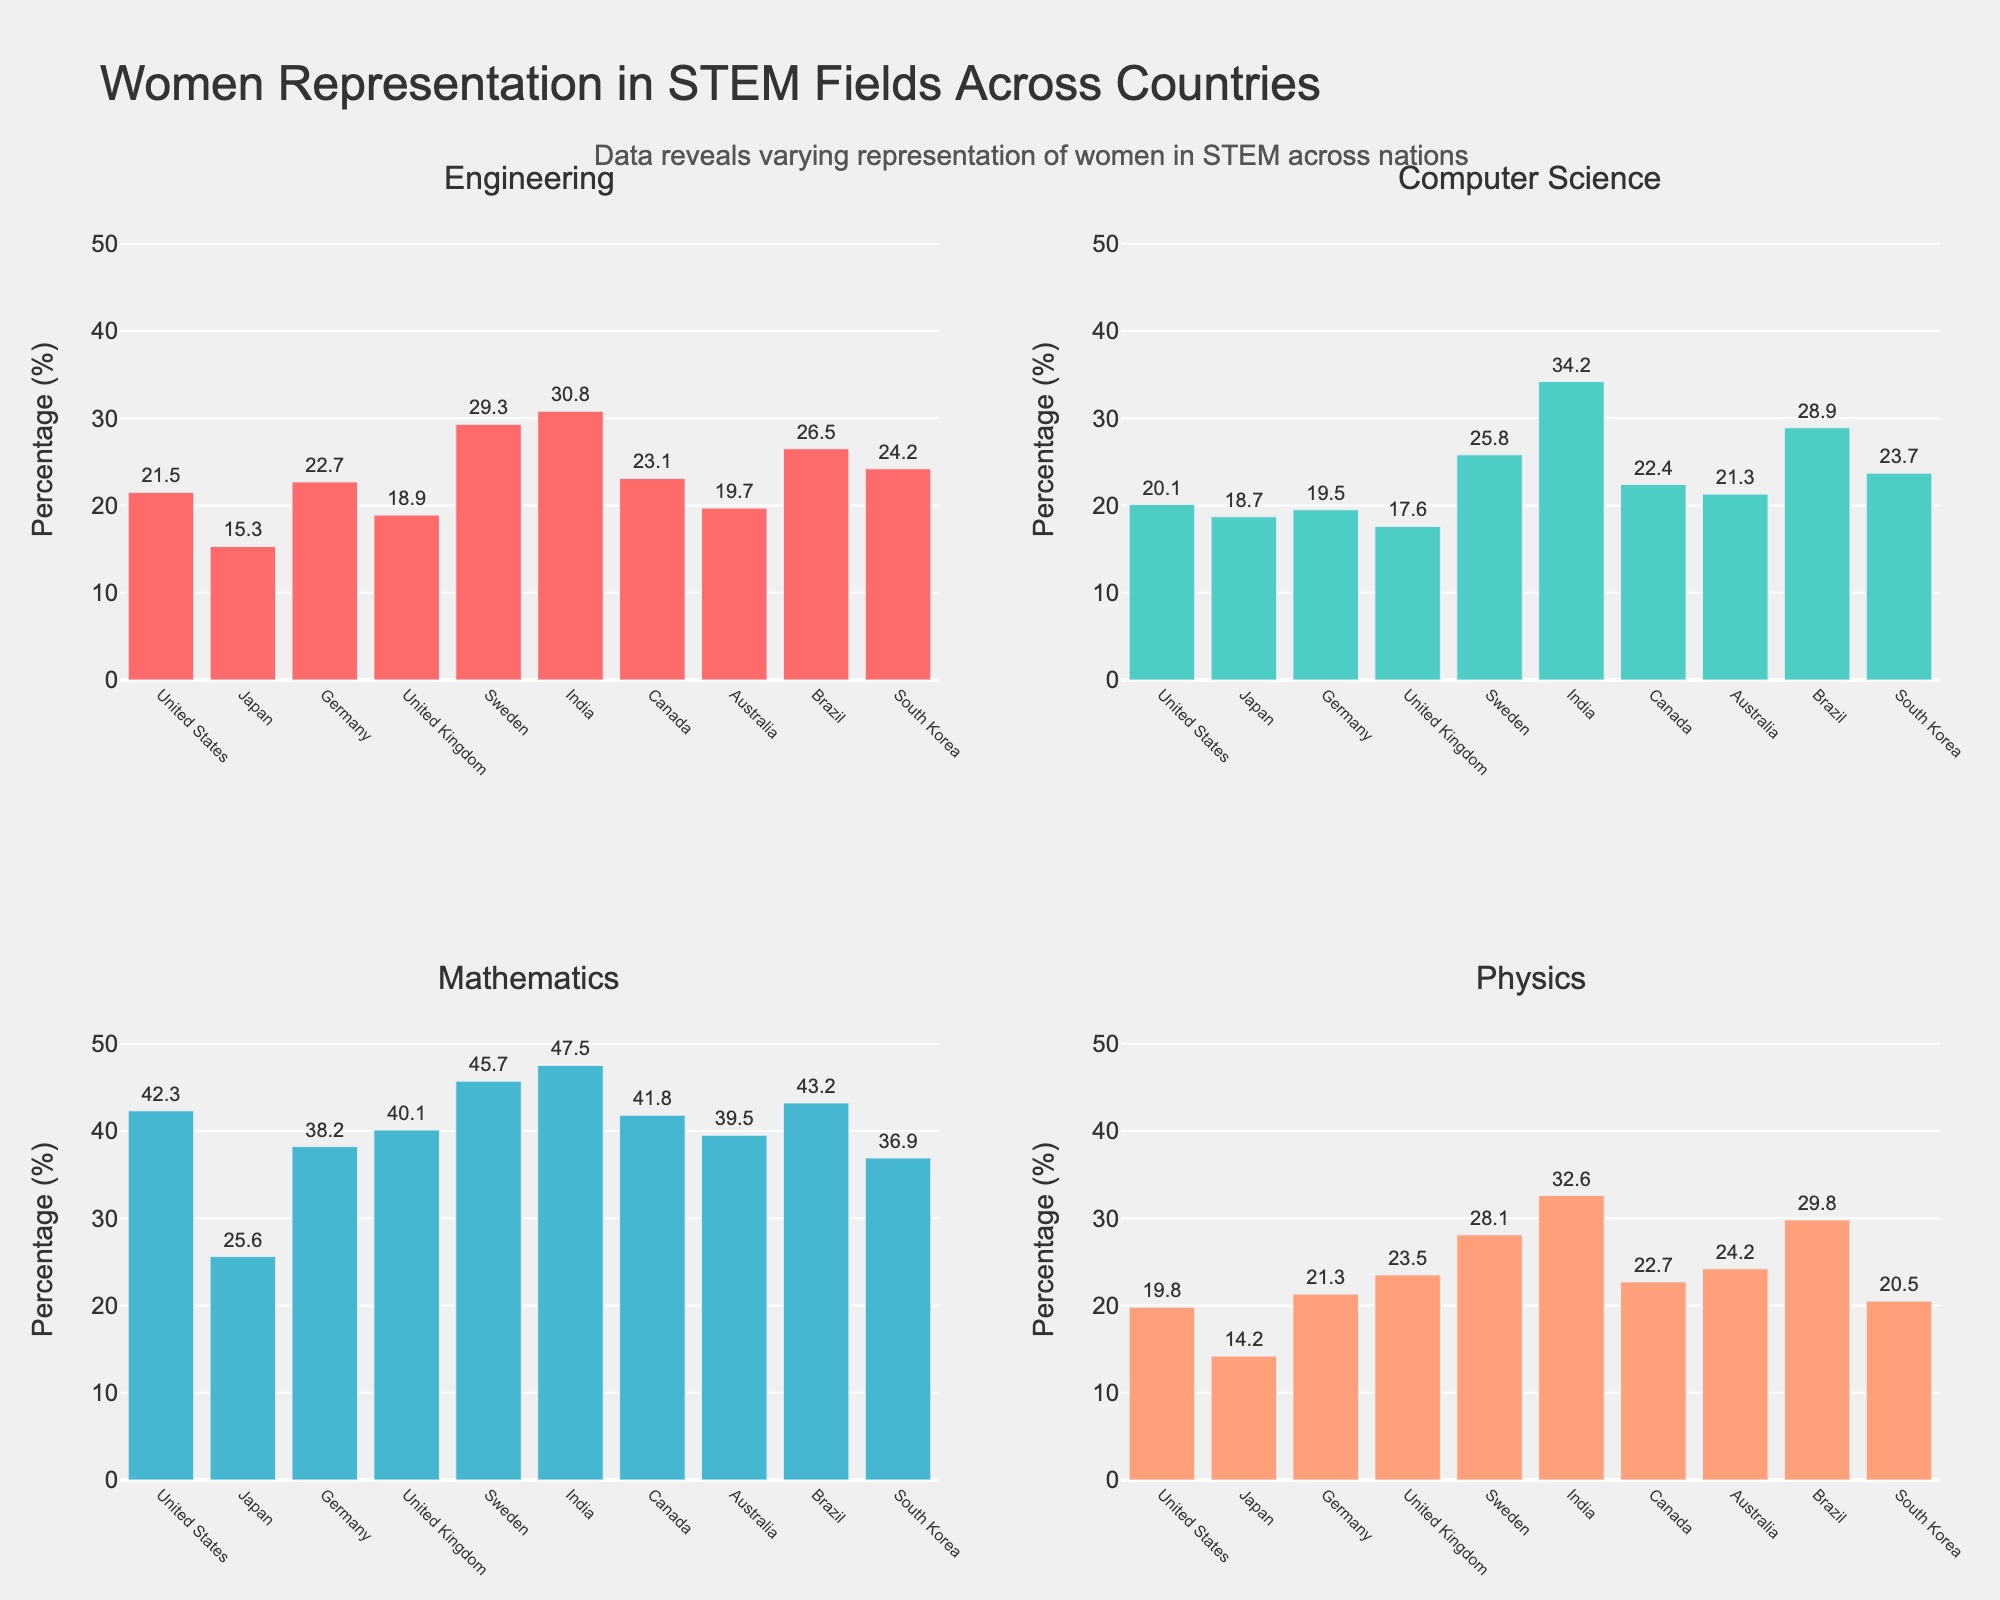How many publications were there in "Nature" in 2022? To answer this, locate the subplot for "Nature" and check the data point corresponding to the year 2022.
Answer: 67 Which journal saw the highest number of publications in 2019? Look at the subplots and identify the highest publication number in 2019. The subplot where this value appears indicates the journal with the highest publications.
Answer: ACS Sustainable Chemistry & Engineering Between which two consecutive years did "Biomacromolecules" see the greatest increase in publications? Identify the "Biomacromolecules" subplot and calculate the year-to-year publication differences; the greatest difference will indicate the years in question.
Answer: 2013-2014 What is the average number of publications across all journals in 2020? Sum the number of publications for 2020 across all journals and divide by the total number of journals. The journals are: Nature, Science, ACS Sustainable Chemistry & Engineering, Biomacromolecules, and Green Chemistry. The calculation is (50 + 39 + 135 + 130 + 131) / 5.
Answer: 97 Which journal experienced a consistent increase in the number of publications every year from 2013 to 2022? Examine the trends in each subplot to see which journal shows a year-by-year increase without any dips over the specified timeframe.
Answer: All journals In which year did "ACS Sustainable Chemistry & Engineering" surpass 100 publications? Check the subplot for "ACS Sustainable Chemistry & Engineering," identifying the first year when the publications exceed 100.
Answer: 2018 How many more publications were there in "Green Chemistry" in 2022 compared to 2013? Subtract the number of publications in 2013 from those in 2022 on the "Green Chemistry" subplot. This can be calculated as 156 - 62.
Answer: 94 What is the combined number of publications in "Science" and "Nature" in 2017? Add the number of publications for "Science" and "Nature" in 2017. This can be calculated as 21 + 28.
Answer: 49 Which journal had the steadiest growth rate in publications from 2013 to 2022? Examine the slopes of the lines in each subplot to identify which journal's trend line is the smoothest and most linear.
Answer: Nature 